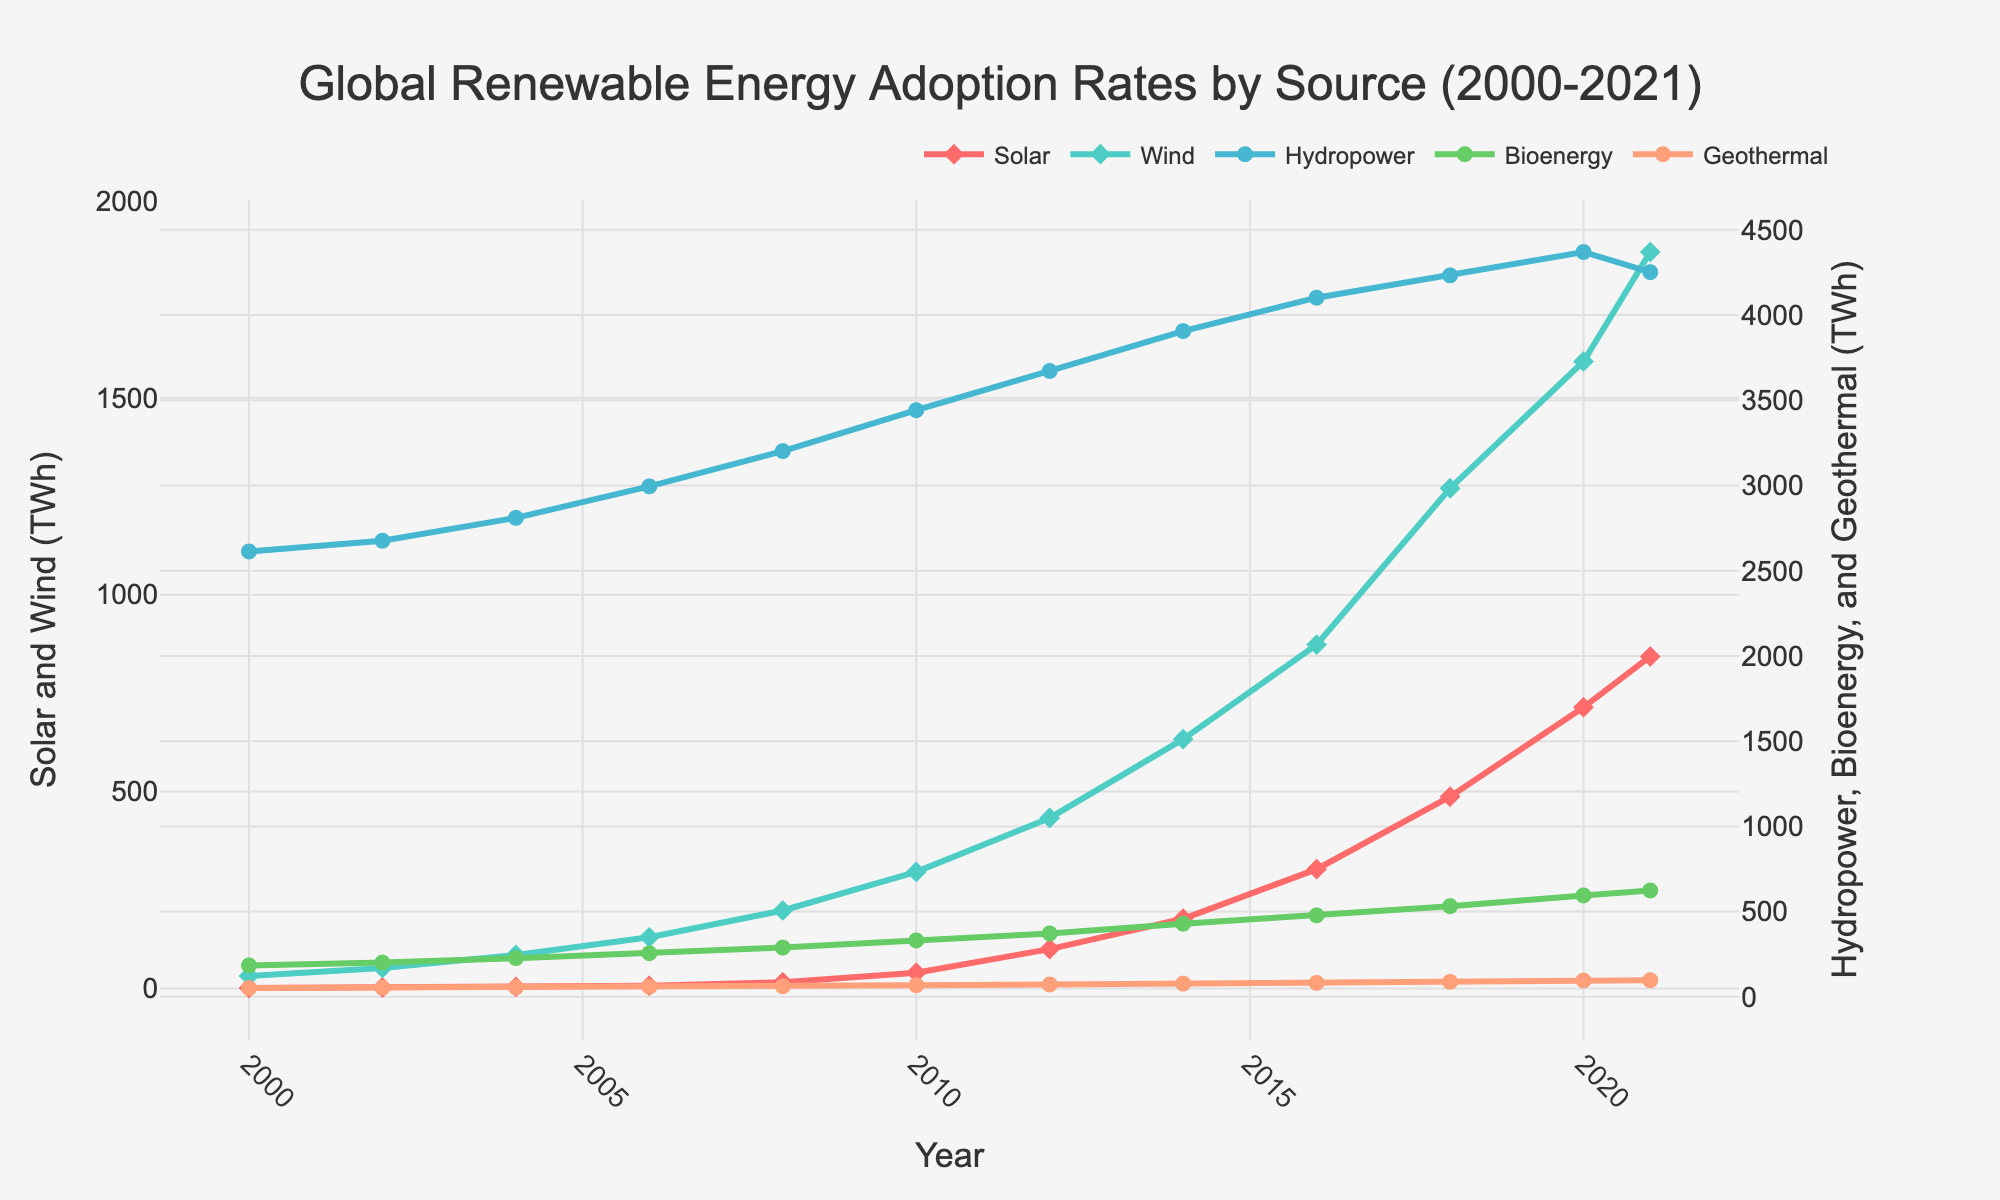What is the total combined increase in solar energy adoption from 2000 to 2021? To find the total combined increase, subtract the adoption rate in 2000 from that in 2021. The rates are 843 TWh in 2021 and 1.2 TWh in 2000. So, 843 - 1.2 = 841.8 TWh.
Answer: 841.8 TWh Which energy source experienced the highest growth rate between 2000 and 2021? To determine the highest growth rate, compare the differences for each source from 2000 to 2021. Solar increased from 1.2 to 843 TWh, Wind from 31.5 to 1870 TWh, Hydropower from 2613 to 4252 TWh, Bioenergy from 184.5 to 624 TWh, and Geothermal from 51.8 to 97.5 TWh. Wind saw the highest increase.
Answer: Wind Between 2010 and 2020, which renewable energy source had the most consistent growth trend? By visually examining the plot, look for the smoothest and most linear increase between 2010 and 2020. Solar shows the most consistent and steadily increasing growth during these years.
Answer: Solar How many times more wind energy was adopted in 2021 compared to 2000? To find this, divide the adoption rate in 2021 by that in 2000. Wind energy in 2021 is 1870 TWh and in 2000 it was 31.5 TWh. So, 1870 / 31.5 ≈ 59.37 times more.
Answer: ~59.37 times Which year saw the largest single-year increase in solar energy adoption? By observing the plot, the largest single-year increase can be seen between years. The sharpest increase appears to be between 2014 and 2016 where it goes from 177 TWh to 303 TWh.
Answer: Between 2014 and 2016 What is the average adoption rate of hydropower between 2000 and 2021? To find the average, add the adoption rates for the years and divide by the number of years. The adoption rates sum up to 47205 TWh. Average = 47205 / 22 ≈ 2145.68 TWh.
Answer: ~2145.68 TWh How do the adoption rates of bioenergy and geothermal compare in 2021? In 2021, bioenergy adoption was 624 TWh and geothermal adoption was 97.5 TWh. Thus, bioenergy adoption was significantly higher than geothermal.
Answer: Bioenergy is significantly higher Which renewable energy source had the smallest total change from 2000 to 2021? To find the smallest total change, compare the increases for each source. Geothermal increased from 51.8 TWh to 97.5 TWh, which is the smallest total change of 45.7 TWh.
Answer: Geothermal From the plot, which color represents wind energy adoption? By visually identifying the colors in the plot, wind energy is represented by the green line and markers.
Answer: Green 